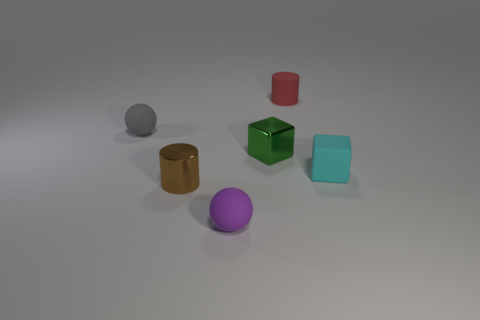Add 3 gray matte spheres. How many objects exist? 9 Add 2 tiny brown cylinders. How many tiny brown cylinders exist? 3 Subtract 0 blue blocks. How many objects are left? 6 Subtract all spheres. How many objects are left? 4 Subtract all tiny green blocks. Subtract all spheres. How many objects are left? 3 Add 4 tiny shiny things. How many tiny shiny things are left? 6 